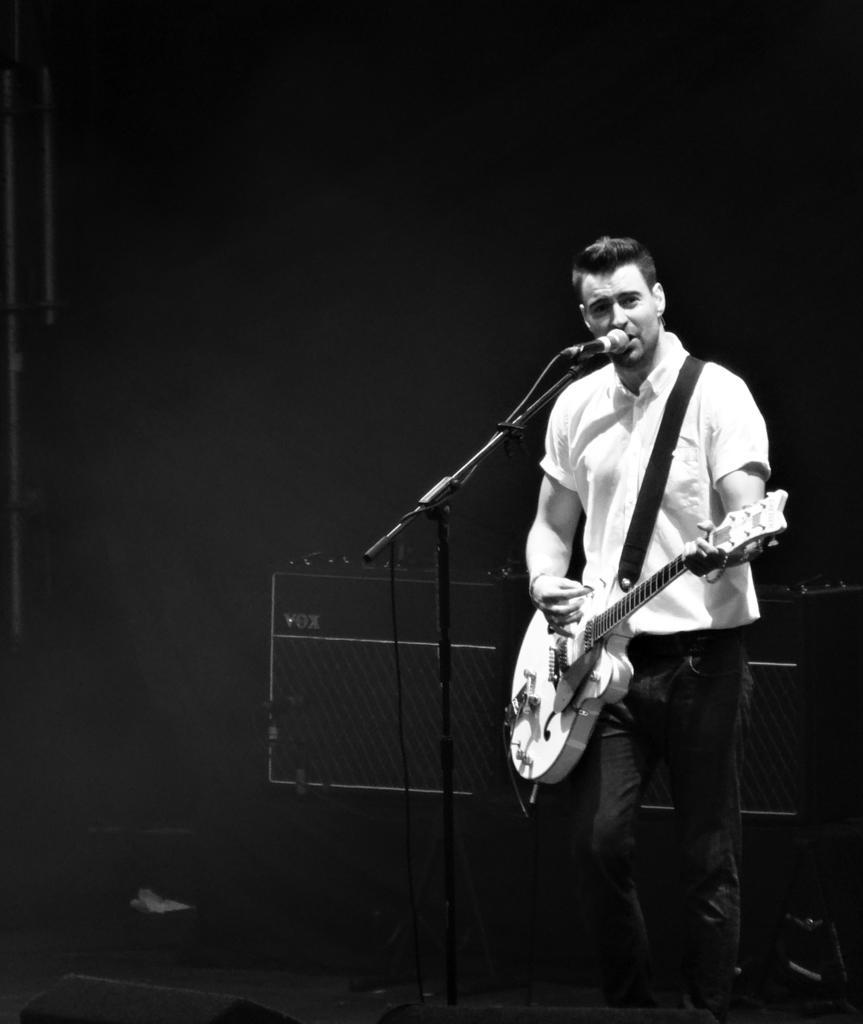In one or two sentences, can you explain what this image depicts? This is a black and white picture. A person is holding a guitar and singing. In front of him there is a mic and a mic stand. 